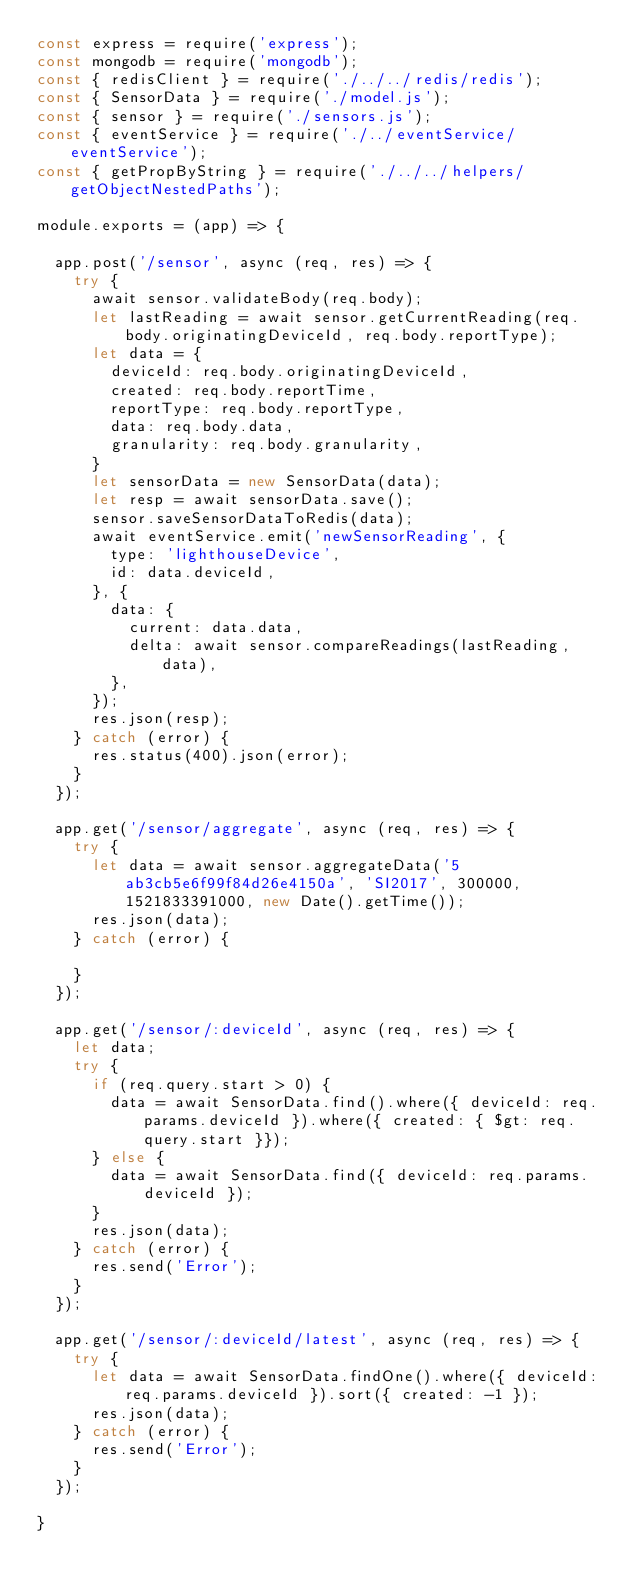<code> <loc_0><loc_0><loc_500><loc_500><_JavaScript_>const express = require('express');
const mongodb = require('mongodb');
const { redisClient } = require('./../../redis/redis');
const { SensorData } = require('./model.js');
const { sensor } = require('./sensors.js');
const { eventService } = require('./../eventService/eventService');
const { getPropByString } = require('./../../helpers/getObjectNestedPaths');

module.exports = (app) => {

  app.post('/sensor', async (req, res) => {
    try {
      await sensor.validateBody(req.body);
      let lastReading = await sensor.getCurrentReading(req.body.originatingDeviceId, req.body.reportType);
      let data = {
        deviceId: req.body.originatingDeviceId,
        created: req.body.reportTime,
        reportType: req.body.reportType,
        data: req.body.data,
        granularity: req.body.granularity,
      }
      let sensorData = new SensorData(data);
      let resp = await sensorData.save();
      sensor.saveSensorDataToRedis(data);
      await eventService.emit('newSensorReading', {
        type: 'lighthouseDevice',
        id: data.deviceId,
      }, {
        data: {
          current: data.data,
          delta: await sensor.compareReadings(lastReading, data),
        },
      });
      res.json(resp);
    } catch (error) {
      res.status(400).json(error);
    }
  });

  app.get('/sensor/aggregate', async (req, res) => {
    try {
      let data = await sensor.aggregateData('5ab3cb5e6f99f84d26e4150a', 'SI2017', 300000, 1521833391000, new Date().getTime());
      res.json(data);
    } catch (error) {
      
    }
  });

  app.get('/sensor/:deviceId', async (req, res) => {
    let data;
    try {
      if (req.query.start > 0) {
        data = await SensorData.find().where({ deviceId: req.params.deviceId }).where({ created: { $gt: req.query.start }});
      } else {
        data = await SensorData.find({ deviceId: req.params.deviceId });
      }
      res.json(data);
    } catch (error) {
      res.send('Error');
    }
  });

  app.get('/sensor/:deviceId/latest', async (req, res) => {
    try {
      let data = await SensorData.findOne().where({ deviceId: req.params.deviceId }).sort({ created: -1 });
      res.json(data);
    } catch (error) {
      res.send('Error');
    }
  });

}</code> 